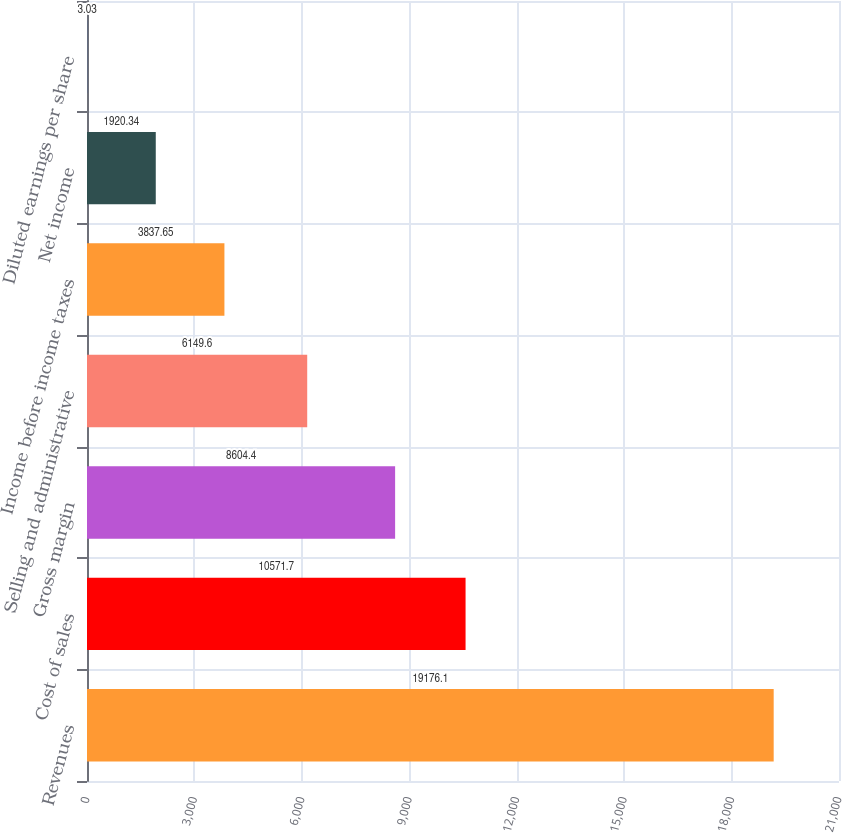Convert chart. <chart><loc_0><loc_0><loc_500><loc_500><bar_chart><fcel>Revenues<fcel>Cost of sales<fcel>Gross margin<fcel>Selling and administrative<fcel>Income before income taxes<fcel>Net income<fcel>Diluted earnings per share<nl><fcel>19176.1<fcel>10571.7<fcel>8604.4<fcel>6149.6<fcel>3837.65<fcel>1920.34<fcel>3.03<nl></chart> 